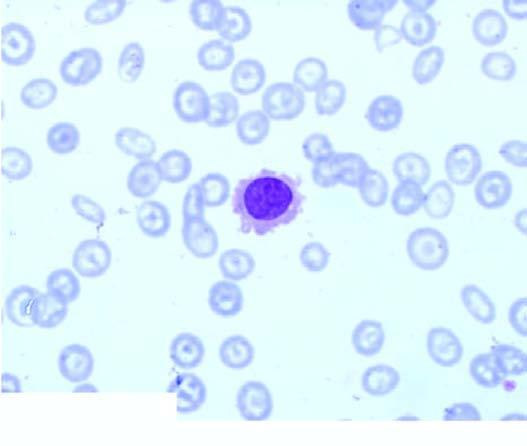does the two red cell enzyme defects, glucose-6 phosphate dehydrogenase and pyruvate kinase, show replacement of marrow spaces with abnormal mononuclear cells?
Answer the question using a single word or phrase. No 